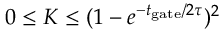<formula> <loc_0><loc_0><loc_500><loc_500>0 \leq K \leq ( 1 - e ^ { { - t _ { g a t e } } / { 2 \tau } } ) ^ { 2 }</formula> 